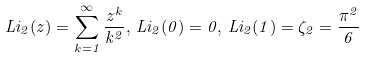Convert formula to latex. <formula><loc_0><loc_0><loc_500><loc_500>L i _ { 2 } ( z ) = \sum _ { k = 1 } ^ { \infty } \frac { z ^ { k } } { k ^ { 2 } } , \, L i _ { 2 } ( 0 ) = 0 , \, L i _ { 2 } ( 1 ) = \zeta _ { 2 } = \frac { \pi ^ { 2 } } { 6 }</formula> 